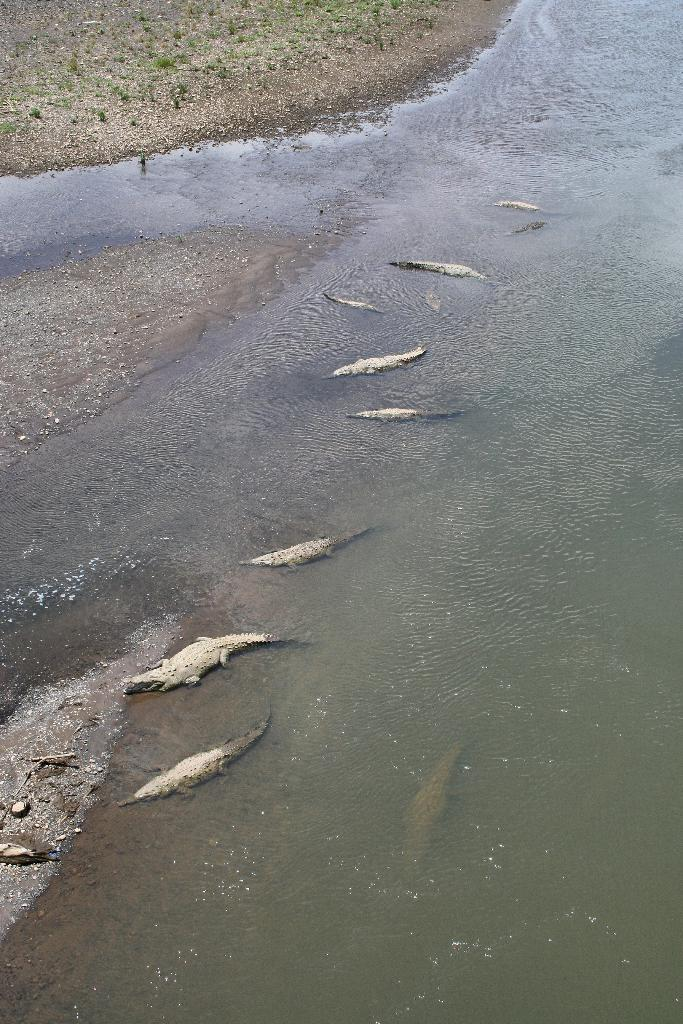Where was the image taken? The image was clicked outside the city. What is the main subject in the center of the image? There are reptiles in a water body in the center of the image. What can be seen in the background of the image? The ground is visible in the background of the image, along with other items. What type of bone can be seen in the image? There is no bone present in the image. How old is the baby in the image? There is no baby present in the image. 